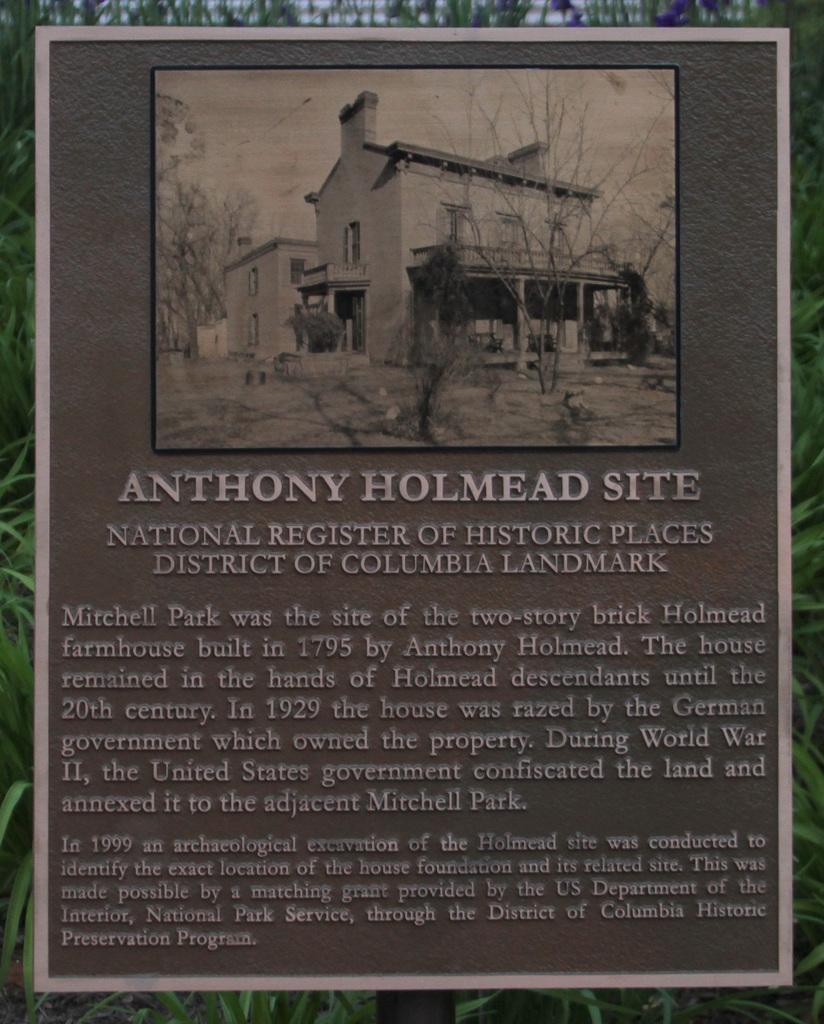In one or two sentences, can you explain what this image depicts? In this image we can see a picture and texts are on a board. In the background we can see the plants. 